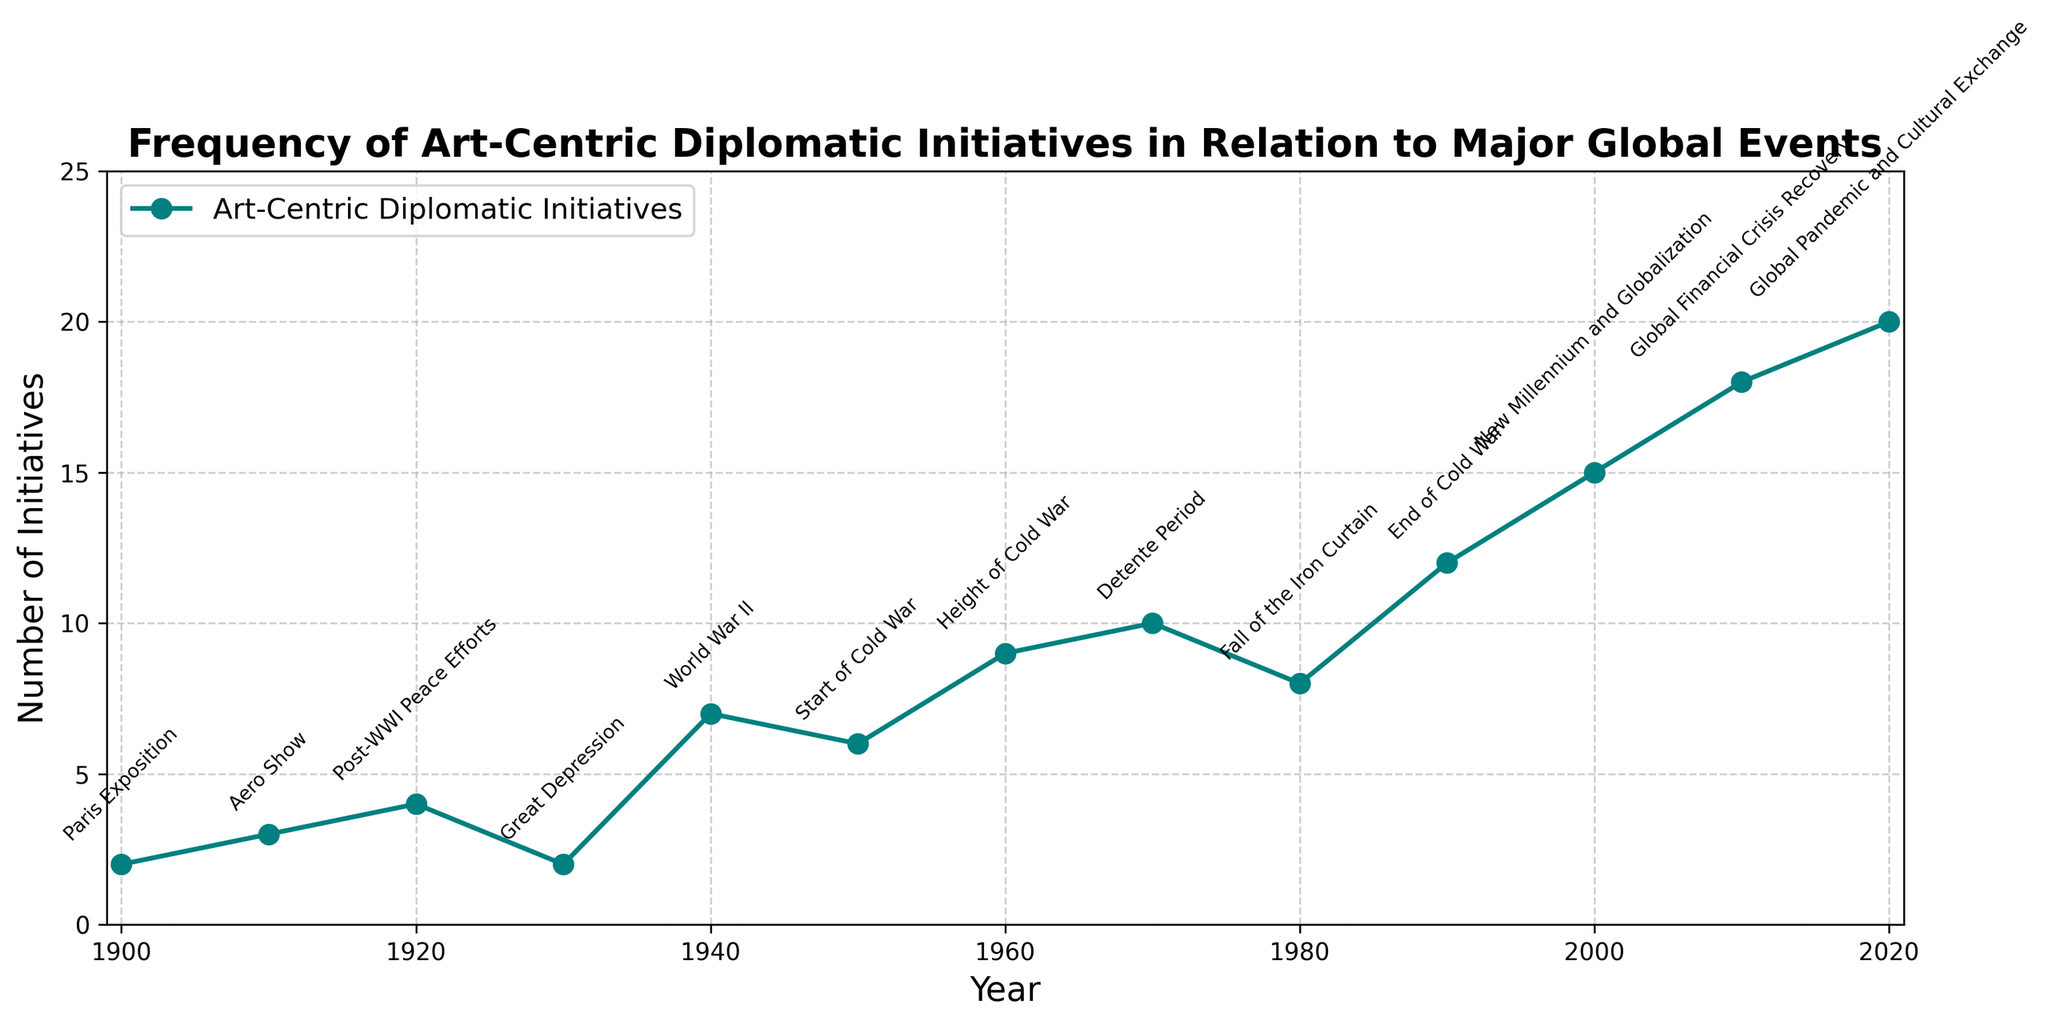What global event corresponds to the highest number of art-centric diplomatic initiatives? According to the line chart, the highest number of art-centric diplomatic initiatives is 20, which occurs in 2020. The major global event annotated at this point is "Global Pandemic and Cultural Exchange."
Answer: Global Pandemic and Cultural Exchange How did the number of initiatives change from 1960 to 1970? In 1960, there were 9 initiatives, and in 1970, there were 10 initiatives. Therefore, the number of initiatives increased by 1 from 1960 to 1970.
Answer: Increased by 1 Which decade experienced the largest increase in the number of initiatives, and what was the increase? To find the decade with the largest increase, we need to compare the initiative counts at the beginning and the end of each decade. The largest increase occurred between 2000 (15 initiatives) and 2010 (18 initiatives), resulting in an increase of 3 initiatives.
Answer: 2000s, increase of 3 How does the number of initiatives in the 1940s compare to those in the 1950s? In the 1940s, there were 7 initiatives, while in the 1950s, there were 6 initiatives. Thus, there were 1 fewer initiative in the 1950s compared to the 1940s.
Answer: 1 fewer in the 1950s What is the overall trend in the number of art-centric diplomatic initiatives from 1900 to 2020? Observing the line chart from 1900 to 2020, there is a clear overall upward trend in the number of art-centric diplomatic initiatives, with noticeable increases at specific points corresponding to major global events.
Answer: Upward trend During which major global event did the number of initiatives double compared to the previous recorded value? In 1940 (World War II), the number of initiatives was 7, doubling from 2 initiatives in 1930 (Great Depression).
Answer: World War II What is the average number of initiatives per decade between 1900 and 2020? To find the average, sum all the initiatives and divide by the number of decades. The sum of initiatives is 2+3+4+2+7+6+9+10+8+12+15+18+20 = 116. There are 13 data points (decades), so the average is 116/13 ≈ 8.92.
Answer: Approximately 8.92 Which decade had the highest average number of initiatives, and what was that average? Calculate the averages: 1940s (7), 1950s (6), 1960s (9), 1970s (10), 1980s (8), 1990s (12), 2000s (15), 2010s (18), 2020 (20, 1 year). The 2020s are not complete, so for the complete decades, the 2010s have the highest average = 18.
Answer: 2010s, average 18 